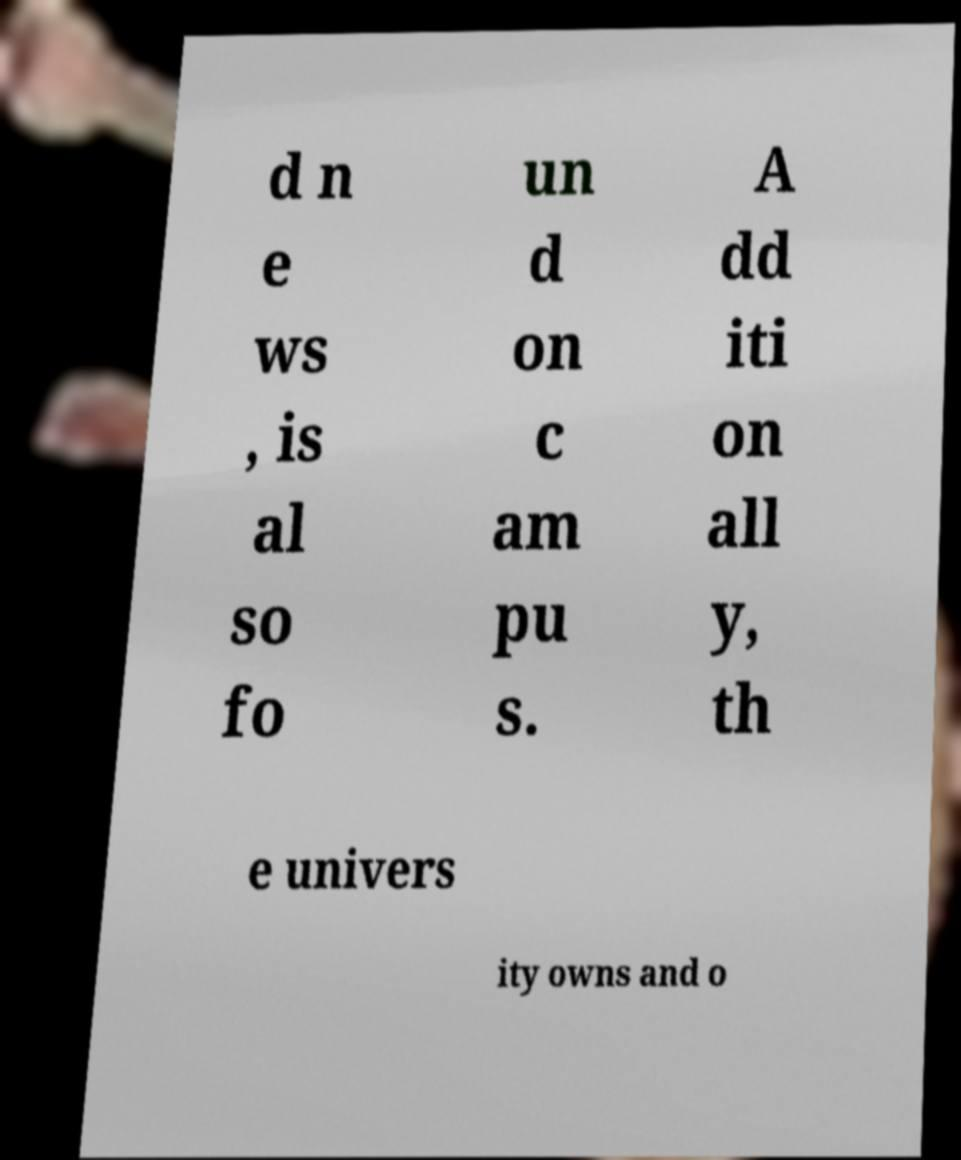Please identify and transcribe the text found in this image. d n e ws , is al so fo un d on c am pu s. A dd iti on all y, th e univers ity owns and o 